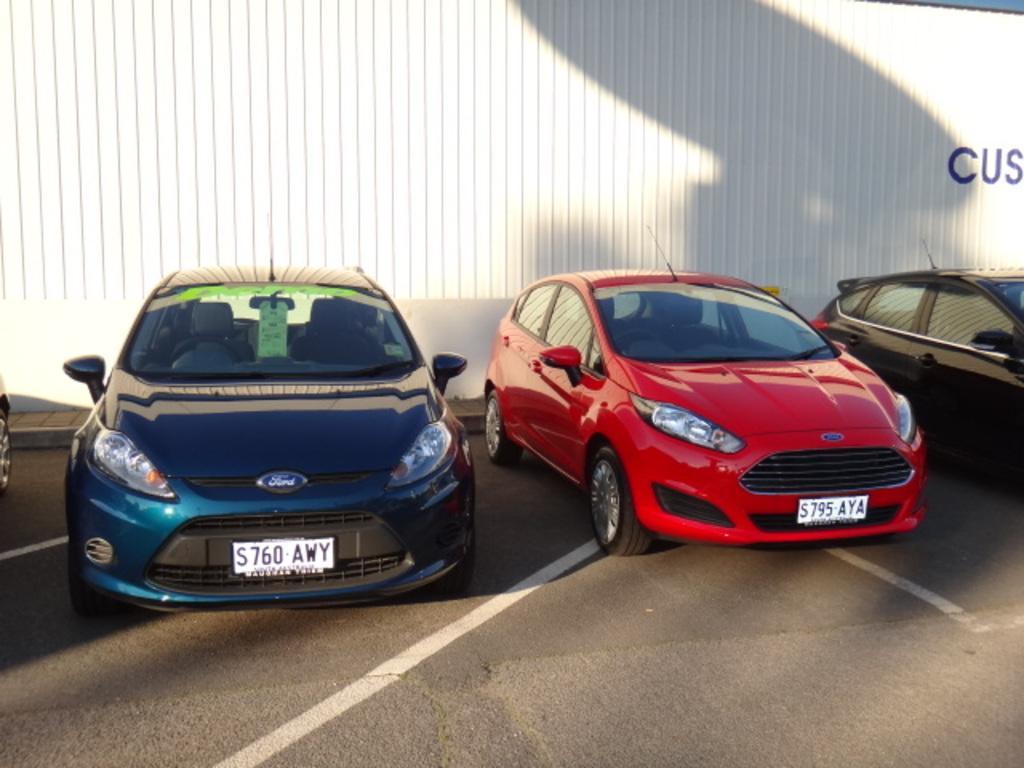Please provide a concise description of this image. In the center of the picture there are cars. In the foreground there is road. In the background there is a white color object might be wall. 